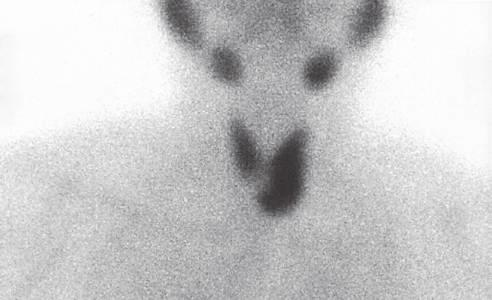s the necrotic ulcer base useful in localizing and distinguishing adenomas from parathyroid hyperplasia, in which more than one gland will demonstrate increased uptake?
Answer the question using a single word or phrase. No 